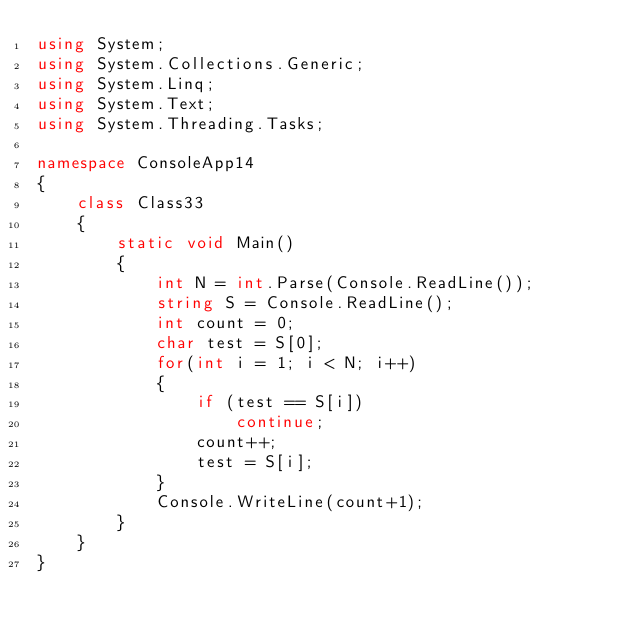Convert code to text. <code><loc_0><loc_0><loc_500><loc_500><_C#_>using System;
using System.Collections.Generic;
using System.Linq;
using System.Text;
using System.Threading.Tasks;

namespace ConsoleApp14
{
    class Class33
    {
        static void Main()
        {
            int N = int.Parse(Console.ReadLine());
            string S = Console.ReadLine();
            int count = 0;
            char test = S[0];
            for(int i = 1; i < N; i++)
            {
                if (test == S[i])
                    continue;
                count++;
                test = S[i];
            }
            Console.WriteLine(count+1);
        }
    }
}
</code> 